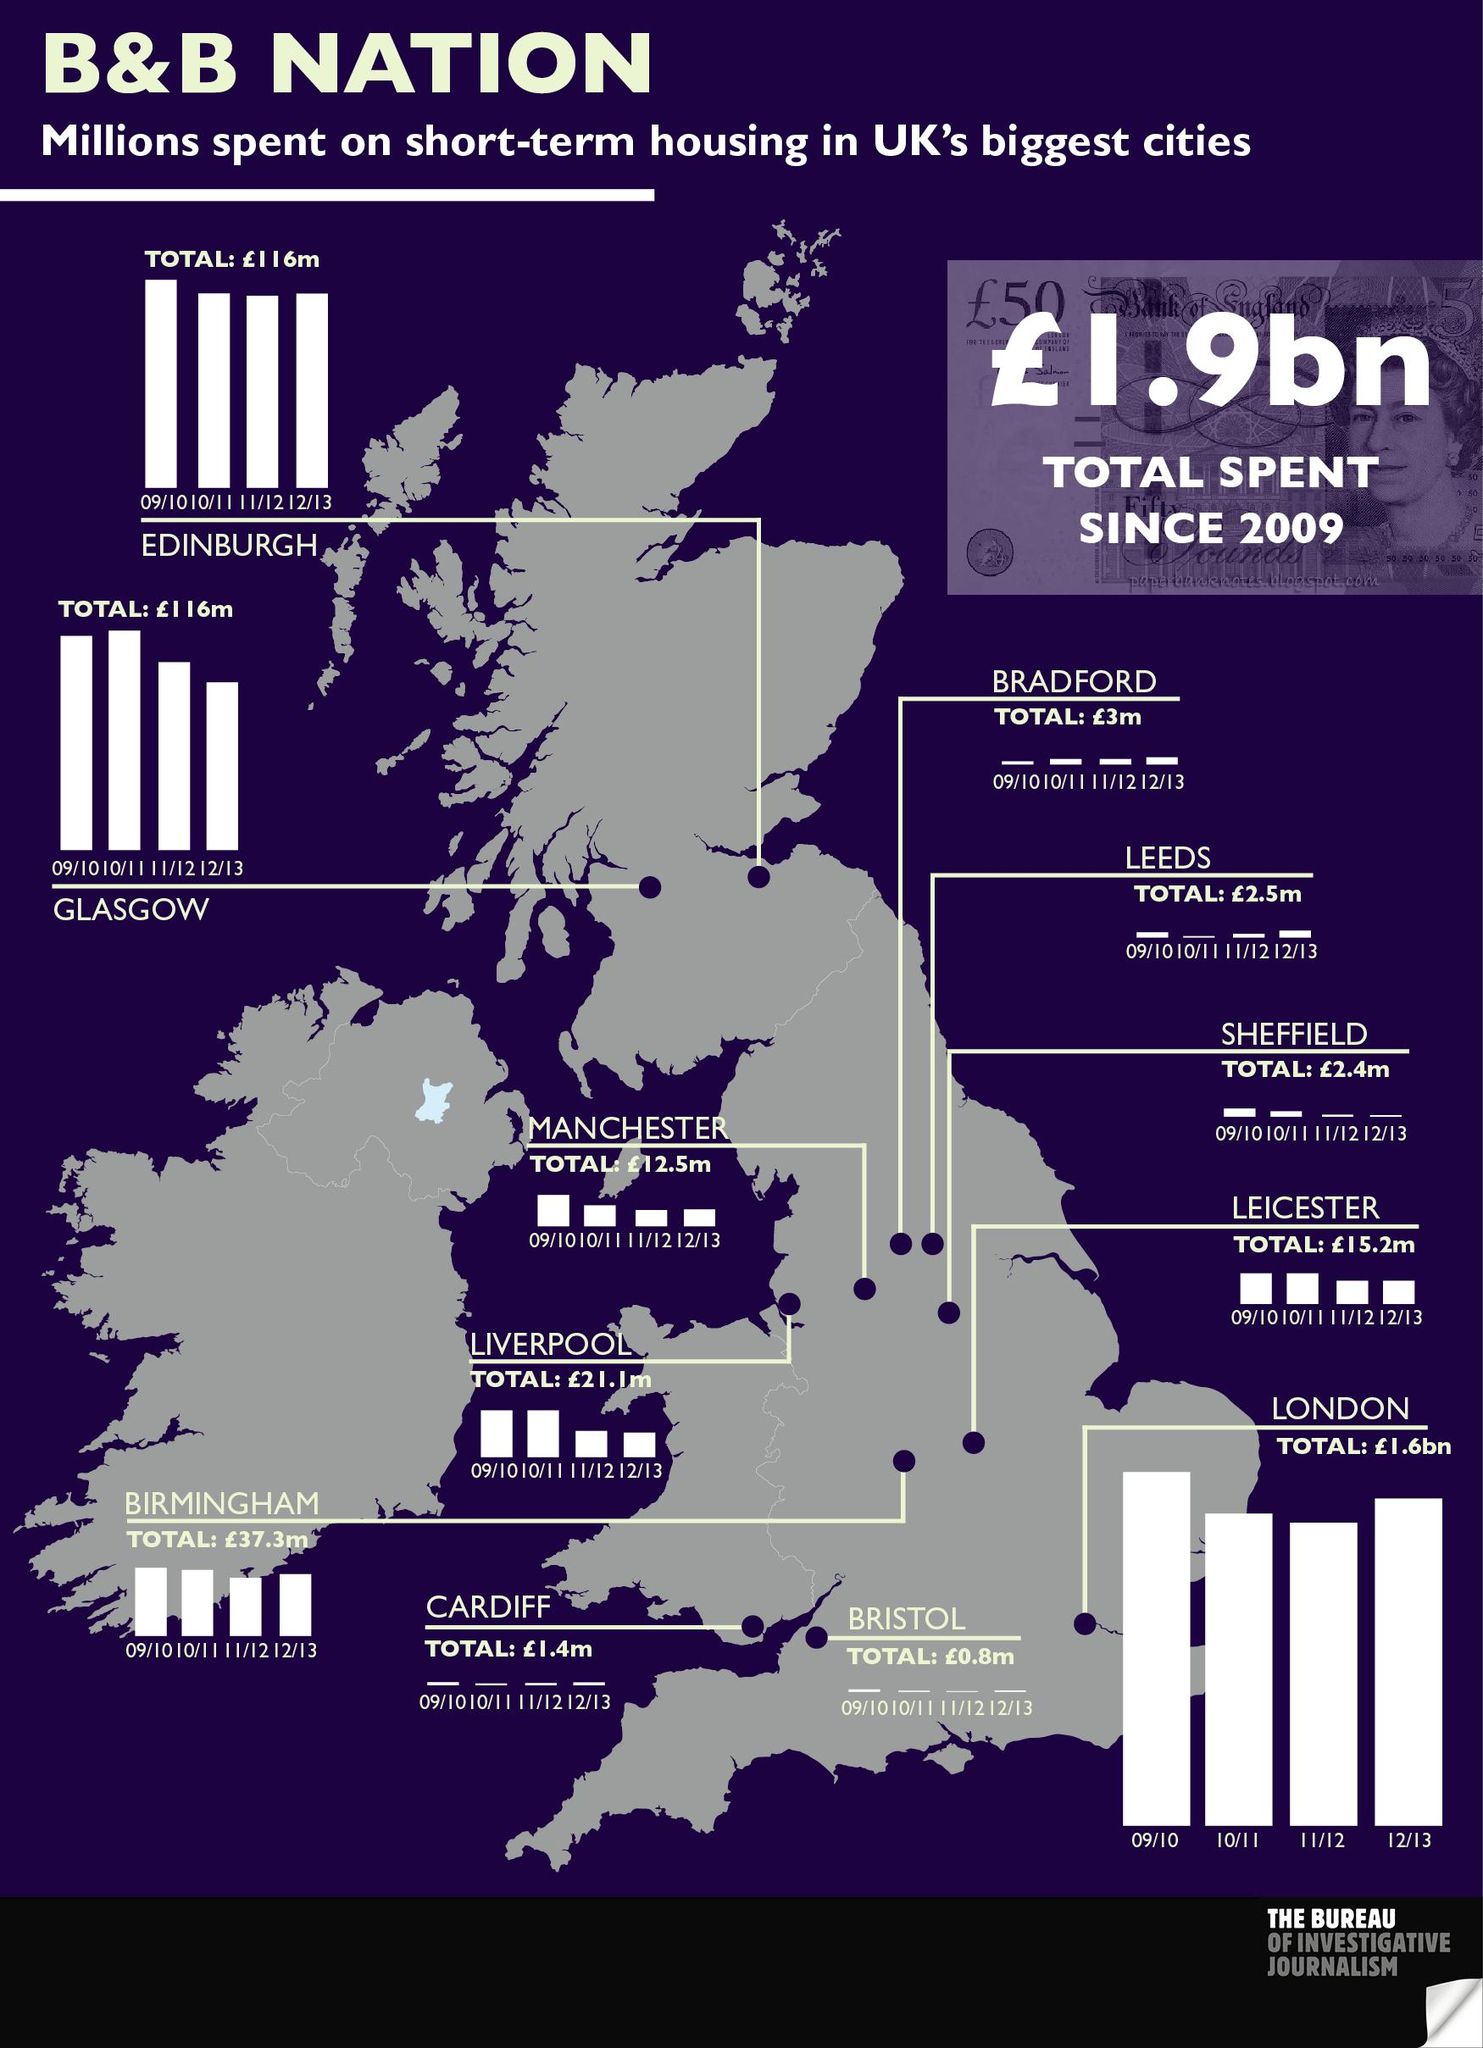Outline some significant characteristics in this image. The total amount spent on short-term housing in Edinburgh, a city in the United Kingdom, from the fiscal year 2009-2010 to 2012-2013 was approximately £116 million. London was the city in the United Kingdom that had the highest total spend on short-term housing from the years 2009 to 2013. The total expenditure on short-term housing in Manchester city of the United Kingdom from the fiscal year 2009-2010 to the fiscal year 2012-2013 was approximately £12.5 million. The total amount spent on short-term housing in Bradford city of the UK from 09/10 -12/13 was approximately £3 million. 